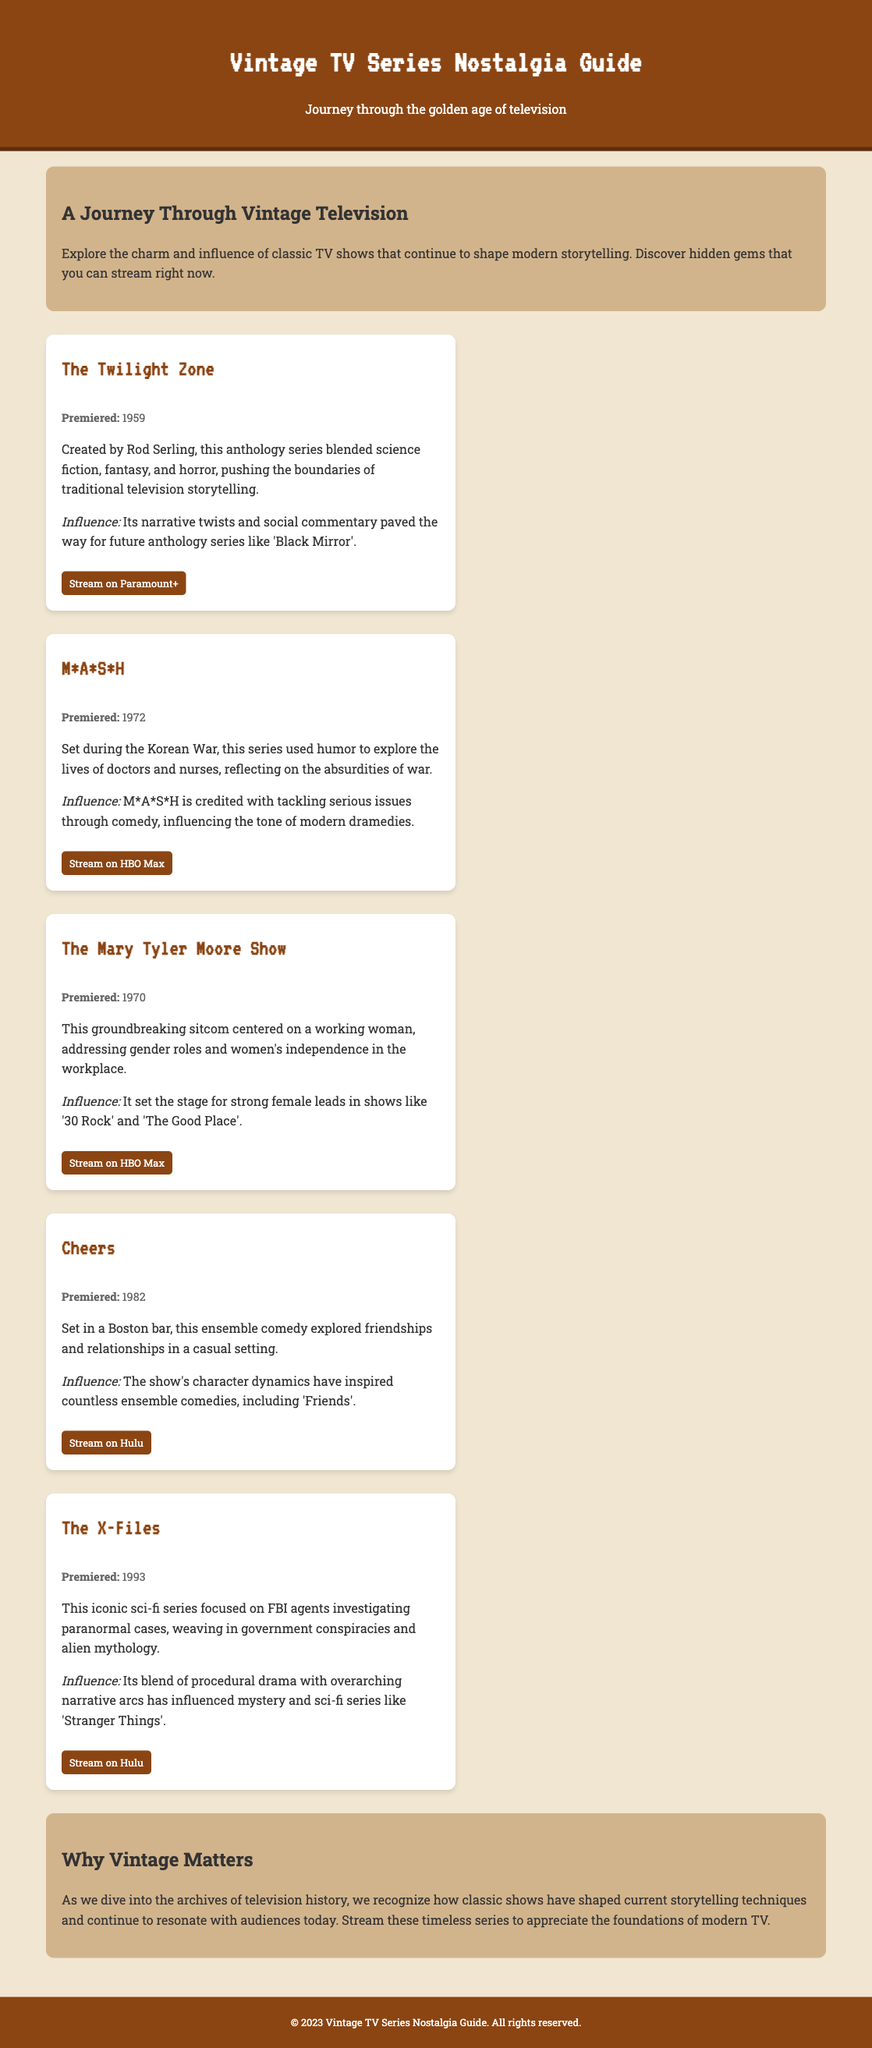What is the title of the guide? The title is prominently displayed at the top of the document, indicating the focus on vintage TV series.
Answer: Vintage TV Series Nostalgia Guide When did The Twilight Zone premiere? The premiere year of each listed show is provided in its respective section.
Answer: 1959 Which platform streams M*A*S*H? Each show includes a platform where it can be streamed, mentioned immediately after the show details.
Answer: HBO Max What is the main theme of The Mary Tyler Moore Show? The theme is briefly described, highlighting its social significance and narrative focus.
Answer: Gender roles and women's independence Which show is noted for influencing modern dramedies? Influences of classic shows on modern television are explicitly stated in their descriptions.
Answer: M*A*S*H In what year did Cheers first air? Premiere dates are listed for each show, which helps identify their historical context.
Answer: 1982 What type of series is The X-Files? The document specifies the genre of each show within its description.
Answer: Sci-fi Which series is recognized for pushing traditional storytelling boundaries? The influence of each show on modern storytelling is mentioned as part of their description.
Answer: The Twilight Zone What does the conclusion highlight about vintage shows? The conclusion section summarizes the importance of vintage TV series in contemporary storytelling.
Answer: Shaped current storytelling techniques 